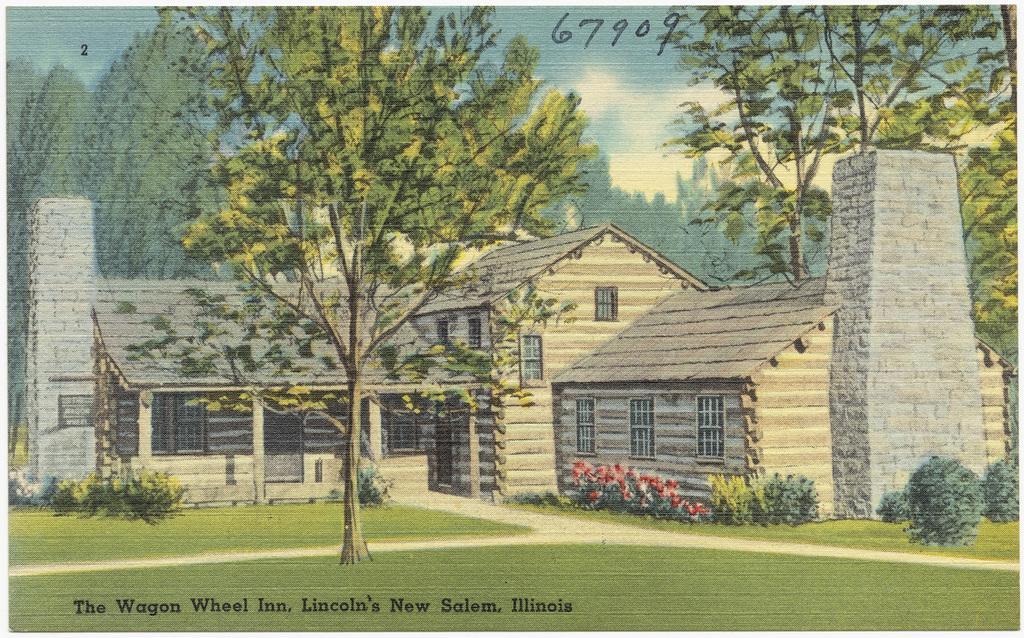Please provide a concise description of this image. In this picture we can see a poster, in this poster we can see houses, trees, plants, text, and grass. In the background of the image we can see the sky with clouds. At the top of the image we can see numbers. 